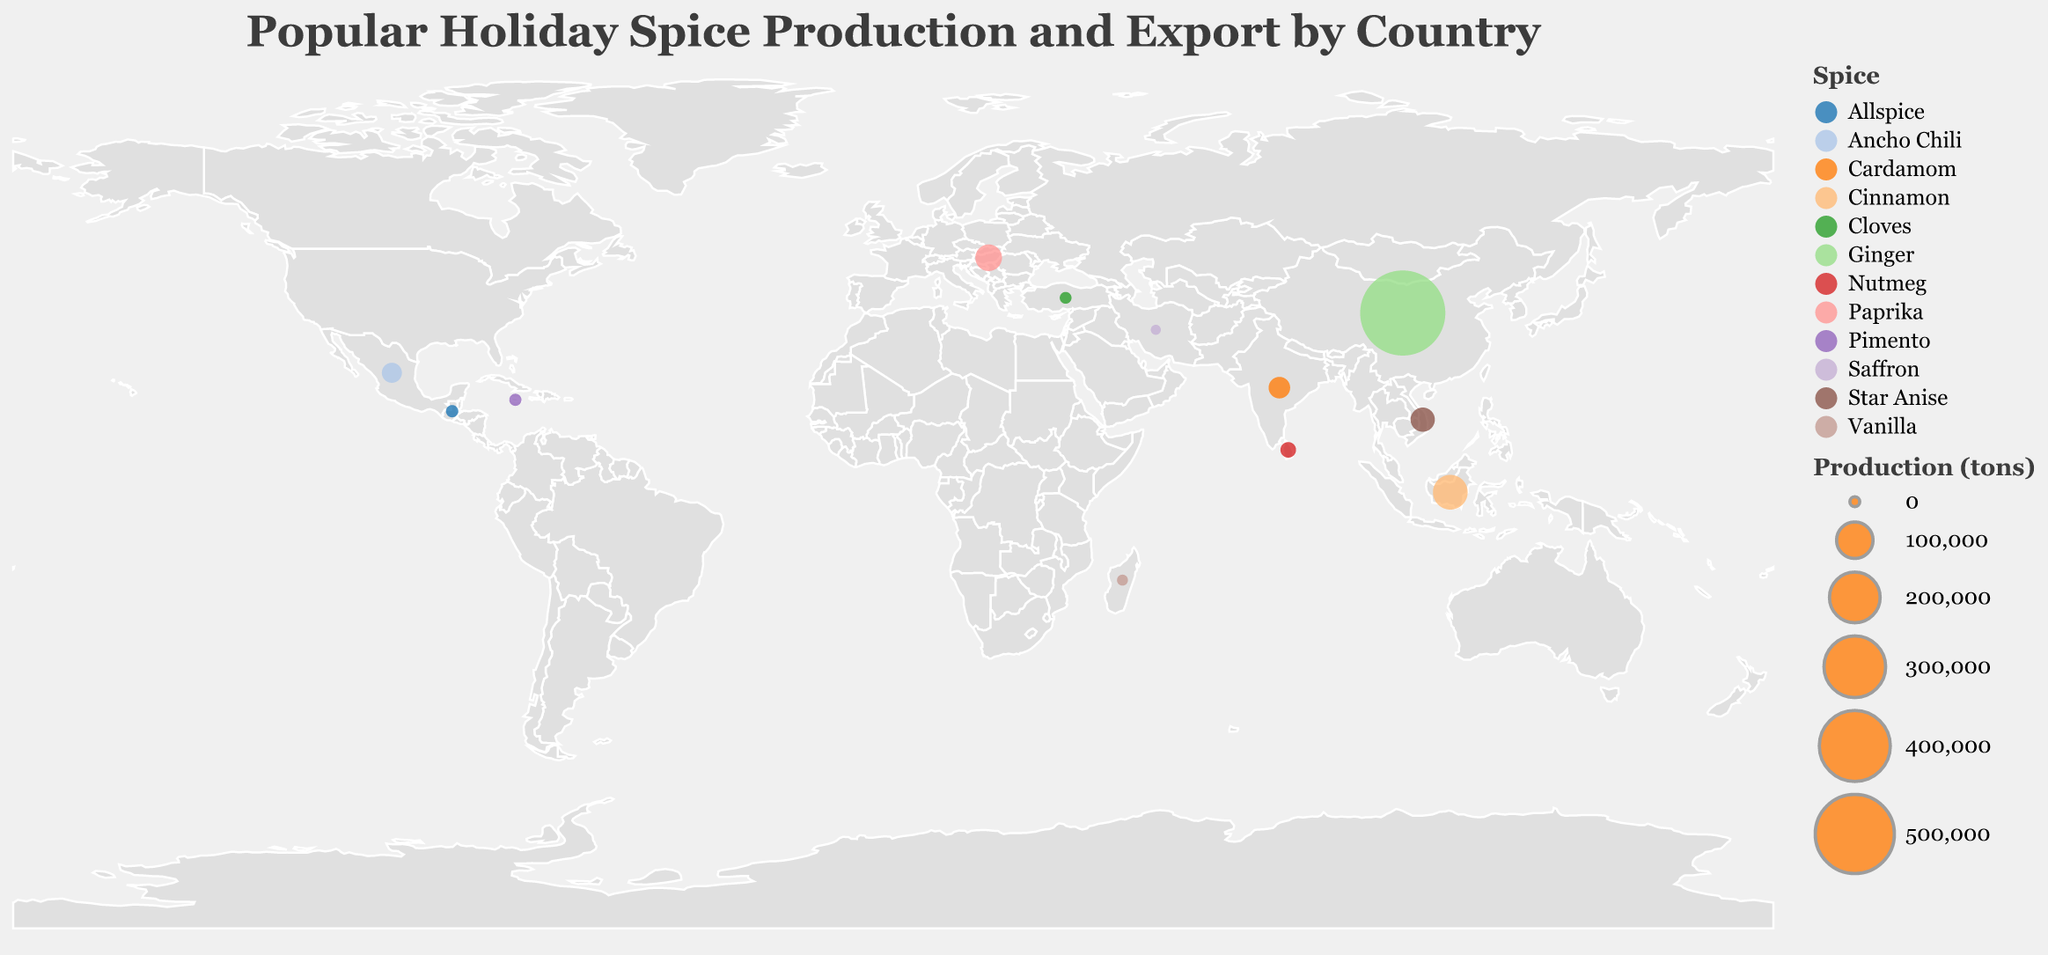What is the title of the figure? The title is found at the top of the figure, indicated in a larger or bolder font. In this case, it reads "Popular Holiday Spice Production and Export by Country."
Answer: Popular Holiday Spice Production and Export by Country Which country produces the most ginger? Examine the size of the circles, as larger circles indicate higher production. The largest circle represents China, producing the most ginger.
Answer: China What color is used to represent Vanilla? Observing the legend, each spice type is associated with a specific color. Vanilla is represented by the color assigned to Madagascar in the plot and legend.
Answer: The color used for Vanilla Which country has the smallest production of spices, and how much is it? Look for the smallest circle on the plot. This circle represents Iran, with the production value indicated in the tooltip.
Answer: Iran, 400 tons What's the total production of spices for Indonesia and India combined? Refer to the production values for both countries and sum them up: 90,000 (Indonesia) + 30,000 (India).
Answer: 120,000 tons Which country exports the highest proportion of its production? Calculate the ratio of exports to production for each country and identify the highest ratio. For example, Madagascar exports 1,800 out of 2,000 tons, giving a ratio of 90%. Review each pair to determine the highest ratio.
Answer: Madagascar How does the production of Ancho Chili in Mexico compare to the production of Paprika in Hungary? Check the production values for both spices in the figure, comparing 25,000 tons (Mexico) to 50,000 tons (Hungary).
Answer: Mexico produces less than Hungary What percentage of ginger produced in China is exported? Calculate the export ratio by dividing the export amount by the production amount and multiplying by 100. For China, it's (450,000 / 580,000) * 100.
Answer: Approximately 77.59% Which spice has its primary production located closest to the equator? Refer to the latitude coordinates for each spice. The closest latitude to 0° is for Indonesia, located near the equator, producing Cinnamon.
Answer: Cinnamon Which country's exported spice amount is closest to its production amount? Compare the export and production values of all countries. The closest match is Madagascar, with 1,800 tons exported out of 2,000 tons produced.
Answer: Madagascar 